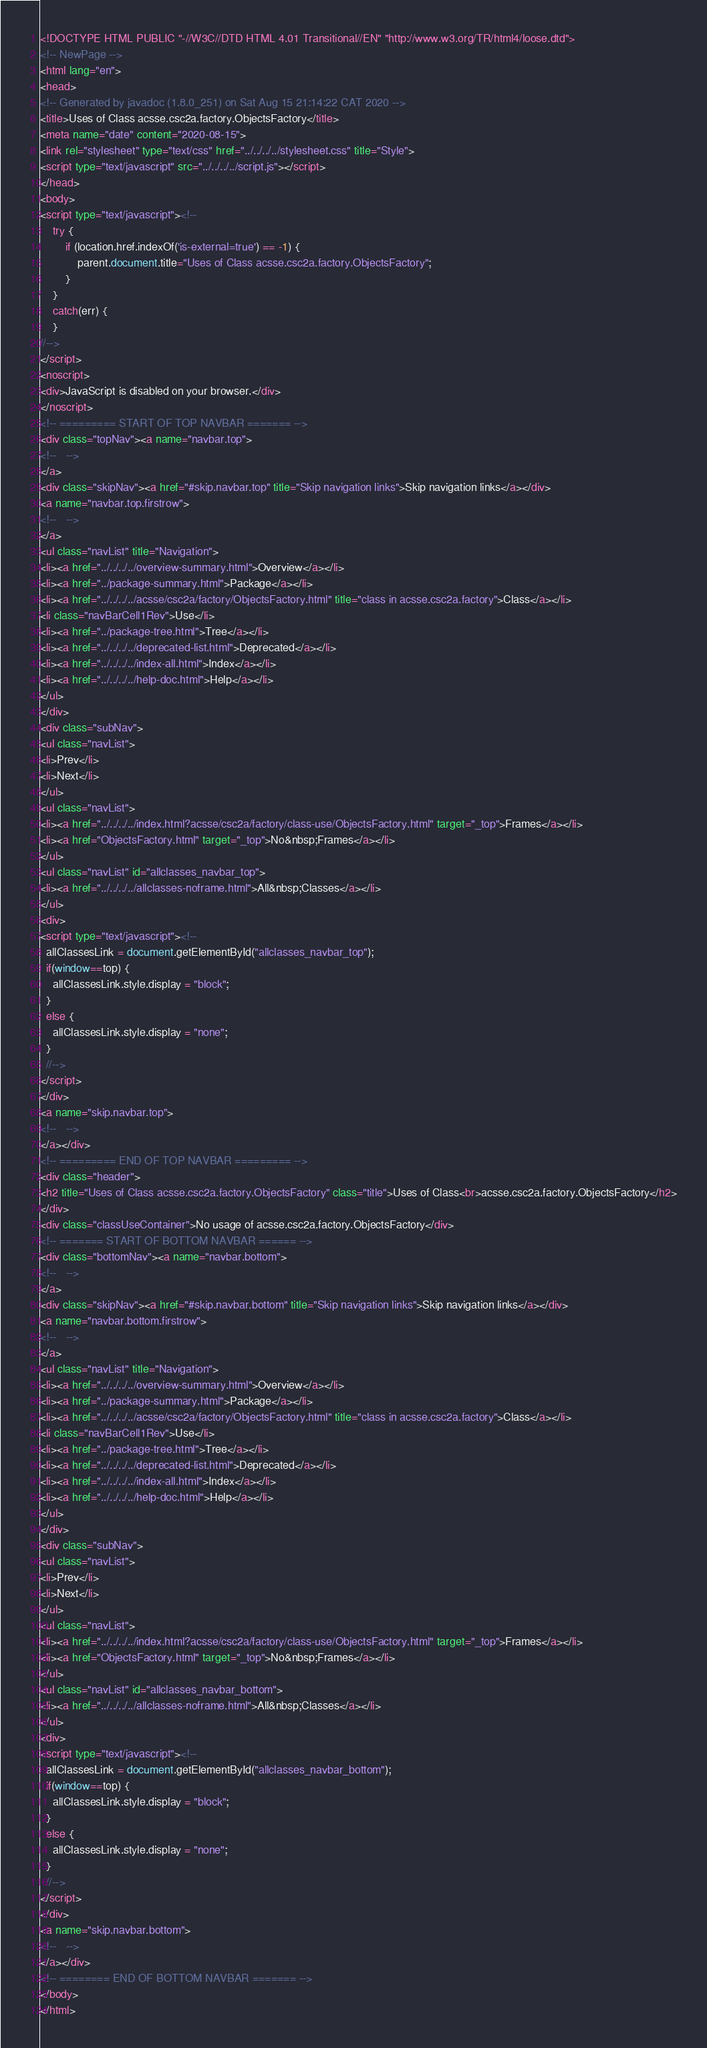<code> <loc_0><loc_0><loc_500><loc_500><_HTML_><!DOCTYPE HTML PUBLIC "-//W3C//DTD HTML 4.01 Transitional//EN" "http://www.w3.org/TR/html4/loose.dtd">
<!-- NewPage -->
<html lang="en">
<head>
<!-- Generated by javadoc (1.8.0_251) on Sat Aug 15 21:14:22 CAT 2020 -->
<title>Uses of Class acsse.csc2a.factory.ObjectsFactory</title>
<meta name="date" content="2020-08-15">
<link rel="stylesheet" type="text/css" href="../../../../stylesheet.css" title="Style">
<script type="text/javascript" src="../../../../script.js"></script>
</head>
<body>
<script type="text/javascript"><!--
    try {
        if (location.href.indexOf('is-external=true') == -1) {
            parent.document.title="Uses of Class acsse.csc2a.factory.ObjectsFactory";
        }
    }
    catch(err) {
    }
//-->
</script>
<noscript>
<div>JavaScript is disabled on your browser.</div>
</noscript>
<!-- ========= START OF TOP NAVBAR ======= -->
<div class="topNav"><a name="navbar.top">
<!--   -->
</a>
<div class="skipNav"><a href="#skip.navbar.top" title="Skip navigation links">Skip navigation links</a></div>
<a name="navbar.top.firstrow">
<!--   -->
</a>
<ul class="navList" title="Navigation">
<li><a href="../../../../overview-summary.html">Overview</a></li>
<li><a href="../package-summary.html">Package</a></li>
<li><a href="../../../../acsse/csc2a/factory/ObjectsFactory.html" title="class in acsse.csc2a.factory">Class</a></li>
<li class="navBarCell1Rev">Use</li>
<li><a href="../package-tree.html">Tree</a></li>
<li><a href="../../../../deprecated-list.html">Deprecated</a></li>
<li><a href="../../../../index-all.html">Index</a></li>
<li><a href="../../../../help-doc.html">Help</a></li>
</ul>
</div>
<div class="subNav">
<ul class="navList">
<li>Prev</li>
<li>Next</li>
</ul>
<ul class="navList">
<li><a href="../../../../index.html?acsse/csc2a/factory/class-use/ObjectsFactory.html" target="_top">Frames</a></li>
<li><a href="ObjectsFactory.html" target="_top">No&nbsp;Frames</a></li>
</ul>
<ul class="navList" id="allclasses_navbar_top">
<li><a href="../../../../allclasses-noframe.html">All&nbsp;Classes</a></li>
</ul>
<div>
<script type="text/javascript"><!--
  allClassesLink = document.getElementById("allclasses_navbar_top");
  if(window==top) {
    allClassesLink.style.display = "block";
  }
  else {
    allClassesLink.style.display = "none";
  }
  //-->
</script>
</div>
<a name="skip.navbar.top">
<!--   -->
</a></div>
<!-- ========= END OF TOP NAVBAR ========= -->
<div class="header">
<h2 title="Uses of Class acsse.csc2a.factory.ObjectsFactory" class="title">Uses of Class<br>acsse.csc2a.factory.ObjectsFactory</h2>
</div>
<div class="classUseContainer">No usage of acsse.csc2a.factory.ObjectsFactory</div>
<!-- ======= START OF BOTTOM NAVBAR ====== -->
<div class="bottomNav"><a name="navbar.bottom">
<!--   -->
</a>
<div class="skipNav"><a href="#skip.navbar.bottom" title="Skip navigation links">Skip navigation links</a></div>
<a name="navbar.bottom.firstrow">
<!--   -->
</a>
<ul class="navList" title="Navigation">
<li><a href="../../../../overview-summary.html">Overview</a></li>
<li><a href="../package-summary.html">Package</a></li>
<li><a href="../../../../acsse/csc2a/factory/ObjectsFactory.html" title="class in acsse.csc2a.factory">Class</a></li>
<li class="navBarCell1Rev">Use</li>
<li><a href="../package-tree.html">Tree</a></li>
<li><a href="../../../../deprecated-list.html">Deprecated</a></li>
<li><a href="../../../../index-all.html">Index</a></li>
<li><a href="../../../../help-doc.html">Help</a></li>
</ul>
</div>
<div class="subNav">
<ul class="navList">
<li>Prev</li>
<li>Next</li>
</ul>
<ul class="navList">
<li><a href="../../../../index.html?acsse/csc2a/factory/class-use/ObjectsFactory.html" target="_top">Frames</a></li>
<li><a href="ObjectsFactory.html" target="_top">No&nbsp;Frames</a></li>
</ul>
<ul class="navList" id="allclasses_navbar_bottom">
<li><a href="../../../../allclasses-noframe.html">All&nbsp;Classes</a></li>
</ul>
<div>
<script type="text/javascript"><!--
  allClassesLink = document.getElementById("allclasses_navbar_bottom");
  if(window==top) {
    allClassesLink.style.display = "block";
  }
  else {
    allClassesLink.style.display = "none";
  }
  //-->
</script>
</div>
<a name="skip.navbar.bottom">
<!--   -->
</a></div>
<!-- ======== END OF BOTTOM NAVBAR ======= -->
</body>
</html>
</code> 